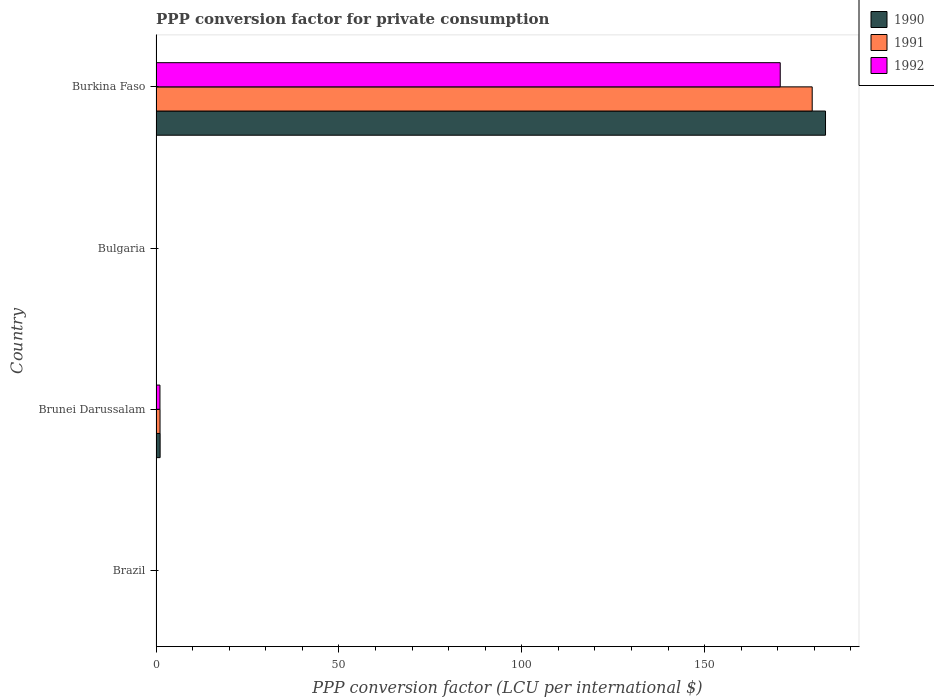How many different coloured bars are there?
Make the answer very short. 3. Are the number of bars on each tick of the Y-axis equal?
Provide a short and direct response. Yes. How many bars are there on the 4th tick from the top?
Give a very brief answer. 3. What is the label of the 3rd group of bars from the top?
Your answer should be compact. Brunei Darussalam. In how many cases, is the number of bars for a given country not equal to the number of legend labels?
Keep it short and to the point. 0. What is the PPP conversion factor for private consumption in 1990 in Brunei Darussalam?
Provide a succinct answer. 1.12. Across all countries, what is the maximum PPP conversion factor for private consumption in 1991?
Make the answer very short. 179.42. Across all countries, what is the minimum PPP conversion factor for private consumption in 1990?
Provide a succinct answer. 2.39117107766808e-5. In which country was the PPP conversion factor for private consumption in 1990 maximum?
Make the answer very short. Burkina Faso. What is the total PPP conversion factor for private consumption in 1991 in the graph?
Offer a very short reply. 180.51. What is the difference between the PPP conversion factor for private consumption in 1990 in Brazil and that in Bulgaria?
Give a very brief answer. -0. What is the difference between the PPP conversion factor for private consumption in 1990 in Brazil and the PPP conversion factor for private consumption in 1991 in Bulgaria?
Your answer should be very brief. -0. What is the average PPP conversion factor for private consumption in 1990 per country?
Ensure brevity in your answer.  46.04. What is the difference between the PPP conversion factor for private consumption in 1990 and PPP conversion factor for private consumption in 1991 in Brunei Darussalam?
Make the answer very short. 0.03. In how many countries, is the PPP conversion factor for private consumption in 1990 greater than 90 LCU?
Keep it short and to the point. 1. What is the ratio of the PPP conversion factor for private consumption in 1992 in Brazil to that in Brunei Darussalam?
Provide a short and direct response. 0. Is the PPP conversion factor for private consumption in 1992 in Brazil less than that in Brunei Darussalam?
Give a very brief answer. Yes. What is the difference between the highest and the second highest PPP conversion factor for private consumption in 1992?
Make the answer very short. 169.6. What is the difference between the highest and the lowest PPP conversion factor for private consumption in 1990?
Your answer should be compact. 183.06. Is the sum of the PPP conversion factor for private consumption in 1991 in Brunei Darussalam and Burkina Faso greater than the maximum PPP conversion factor for private consumption in 1990 across all countries?
Keep it short and to the point. No. What does the 3rd bar from the top in Brunei Darussalam represents?
Offer a terse response. 1990. Is it the case that in every country, the sum of the PPP conversion factor for private consumption in 1992 and PPP conversion factor for private consumption in 1990 is greater than the PPP conversion factor for private consumption in 1991?
Ensure brevity in your answer.  Yes. Are all the bars in the graph horizontal?
Your answer should be very brief. Yes. What is the difference between two consecutive major ticks on the X-axis?
Ensure brevity in your answer.  50. Does the graph contain any zero values?
Keep it short and to the point. No. Does the graph contain grids?
Your response must be concise. No. How are the legend labels stacked?
Your answer should be compact. Vertical. What is the title of the graph?
Your response must be concise. PPP conversion factor for private consumption. What is the label or title of the X-axis?
Provide a succinct answer. PPP conversion factor (LCU per international $). What is the PPP conversion factor (LCU per international $) of 1990 in Brazil?
Give a very brief answer. 2.39117107766808e-5. What is the PPP conversion factor (LCU per international $) in 1991 in Brazil?
Your answer should be very brief. 0. What is the PPP conversion factor (LCU per international $) in 1992 in Brazil?
Your answer should be very brief. 0. What is the PPP conversion factor (LCU per international $) in 1990 in Brunei Darussalam?
Give a very brief answer. 1.12. What is the PPP conversion factor (LCU per international $) of 1991 in Brunei Darussalam?
Offer a very short reply. 1.09. What is the PPP conversion factor (LCU per international $) in 1992 in Brunei Darussalam?
Give a very brief answer. 1.08. What is the PPP conversion factor (LCU per international $) of 1990 in Bulgaria?
Provide a short and direct response. 0. What is the PPP conversion factor (LCU per international $) in 1991 in Bulgaria?
Keep it short and to the point. 0. What is the PPP conversion factor (LCU per international $) of 1992 in Bulgaria?
Keep it short and to the point. 0. What is the PPP conversion factor (LCU per international $) in 1990 in Burkina Faso?
Give a very brief answer. 183.06. What is the PPP conversion factor (LCU per international $) in 1991 in Burkina Faso?
Give a very brief answer. 179.42. What is the PPP conversion factor (LCU per international $) in 1992 in Burkina Faso?
Your answer should be compact. 170.67. Across all countries, what is the maximum PPP conversion factor (LCU per international $) in 1990?
Ensure brevity in your answer.  183.06. Across all countries, what is the maximum PPP conversion factor (LCU per international $) of 1991?
Ensure brevity in your answer.  179.42. Across all countries, what is the maximum PPP conversion factor (LCU per international $) in 1992?
Offer a terse response. 170.67. Across all countries, what is the minimum PPP conversion factor (LCU per international $) in 1990?
Keep it short and to the point. 2.39117107766808e-5. Across all countries, what is the minimum PPP conversion factor (LCU per international $) in 1991?
Keep it short and to the point. 0. Across all countries, what is the minimum PPP conversion factor (LCU per international $) in 1992?
Your response must be concise. 0. What is the total PPP conversion factor (LCU per international $) in 1990 in the graph?
Give a very brief answer. 184.18. What is the total PPP conversion factor (LCU per international $) in 1991 in the graph?
Provide a succinct answer. 180.51. What is the total PPP conversion factor (LCU per international $) of 1992 in the graph?
Ensure brevity in your answer.  171.76. What is the difference between the PPP conversion factor (LCU per international $) in 1990 in Brazil and that in Brunei Darussalam?
Your answer should be compact. -1.12. What is the difference between the PPP conversion factor (LCU per international $) in 1991 in Brazil and that in Brunei Darussalam?
Keep it short and to the point. -1.09. What is the difference between the PPP conversion factor (LCU per international $) of 1992 in Brazil and that in Brunei Darussalam?
Your answer should be very brief. -1.07. What is the difference between the PPP conversion factor (LCU per international $) of 1990 in Brazil and that in Bulgaria?
Your answer should be compact. -0. What is the difference between the PPP conversion factor (LCU per international $) in 1991 in Brazil and that in Bulgaria?
Offer a terse response. -0. What is the difference between the PPP conversion factor (LCU per international $) in 1992 in Brazil and that in Bulgaria?
Keep it short and to the point. -0. What is the difference between the PPP conversion factor (LCU per international $) in 1990 in Brazil and that in Burkina Faso?
Your answer should be compact. -183.06. What is the difference between the PPP conversion factor (LCU per international $) of 1991 in Brazil and that in Burkina Faso?
Provide a succinct answer. -179.42. What is the difference between the PPP conversion factor (LCU per international $) of 1992 in Brazil and that in Burkina Faso?
Give a very brief answer. -170.67. What is the difference between the PPP conversion factor (LCU per international $) of 1990 in Brunei Darussalam and that in Bulgaria?
Offer a very short reply. 1.12. What is the difference between the PPP conversion factor (LCU per international $) in 1991 in Brunei Darussalam and that in Bulgaria?
Offer a very short reply. 1.09. What is the difference between the PPP conversion factor (LCU per international $) in 1992 in Brunei Darussalam and that in Bulgaria?
Make the answer very short. 1.07. What is the difference between the PPP conversion factor (LCU per international $) of 1990 in Brunei Darussalam and that in Burkina Faso?
Offer a very short reply. -181.93. What is the difference between the PPP conversion factor (LCU per international $) in 1991 in Brunei Darussalam and that in Burkina Faso?
Make the answer very short. -178.32. What is the difference between the PPP conversion factor (LCU per international $) in 1992 in Brunei Darussalam and that in Burkina Faso?
Provide a short and direct response. -169.6. What is the difference between the PPP conversion factor (LCU per international $) of 1990 in Bulgaria and that in Burkina Faso?
Make the answer very short. -183.06. What is the difference between the PPP conversion factor (LCU per international $) in 1991 in Bulgaria and that in Burkina Faso?
Keep it short and to the point. -179.41. What is the difference between the PPP conversion factor (LCU per international $) of 1992 in Bulgaria and that in Burkina Faso?
Ensure brevity in your answer.  -170.67. What is the difference between the PPP conversion factor (LCU per international $) of 1990 in Brazil and the PPP conversion factor (LCU per international $) of 1991 in Brunei Darussalam?
Your answer should be compact. -1.09. What is the difference between the PPP conversion factor (LCU per international $) of 1990 in Brazil and the PPP conversion factor (LCU per international $) of 1992 in Brunei Darussalam?
Offer a terse response. -1.08. What is the difference between the PPP conversion factor (LCU per international $) of 1991 in Brazil and the PPP conversion factor (LCU per international $) of 1992 in Brunei Darussalam?
Your answer should be very brief. -1.08. What is the difference between the PPP conversion factor (LCU per international $) of 1990 in Brazil and the PPP conversion factor (LCU per international $) of 1991 in Bulgaria?
Offer a terse response. -0. What is the difference between the PPP conversion factor (LCU per international $) in 1990 in Brazil and the PPP conversion factor (LCU per international $) in 1992 in Bulgaria?
Your response must be concise. -0. What is the difference between the PPP conversion factor (LCU per international $) in 1991 in Brazil and the PPP conversion factor (LCU per international $) in 1992 in Bulgaria?
Make the answer very short. -0. What is the difference between the PPP conversion factor (LCU per international $) of 1990 in Brazil and the PPP conversion factor (LCU per international $) of 1991 in Burkina Faso?
Make the answer very short. -179.42. What is the difference between the PPP conversion factor (LCU per international $) of 1990 in Brazil and the PPP conversion factor (LCU per international $) of 1992 in Burkina Faso?
Your response must be concise. -170.67. What is the difference between the PPP conversion factor (LCU per international $) in 1991 in Brazil and the PPP conversion factor (LCU per international $) in 1992 in Burkina Faso?
Give a very brief answer. -170.67. What is the difference between the PPP conversion factor (LCU per international $) in 1990 in Brunei Darussalam and the PPP conversion factor (LCU per international $) in 1991 in Bulgaria?
Make the answer very short. 1.12. What is the difference between the PPP conversion factor (LCU per international $) of 1990 in Brunei Darussalam and the PPP conversion factor (LCU per international $) of 1992 in Bulgaria?
Keep it short and to the point. 1.12. What is the difference between the PPP conversion factor (LCU per international $) of 1991 in Brunei Darussalam and the PPP conversion factor (LCU per international $) of 1992 in Bulgaria?
Ensure brevity in your answer.  1.09. What is the difference between the PPP conversion factor (LCU per international $) of 1990 in Brunei Darussalam and the PPP conversion factor (LCU per international $) of 1991 in Burkina Faso?
Keep it short and to the point. -178.29. What is the difference between the PPP conversion factor (LCU per international $) of 1990 in Brunei Darussalam and the PPP conversion factor (LCU per international $) of 1992 in Burkina Faso?
Ensure brevity in your answer.  -169.55. What is the difference between the PPP conversion factor (LCU per international $) of 1991 in Brunei Darussalam and the PPP conversion factor (LCU per international $) of 1992 in Burkina Faso?
Your answer should be very brief. -169.58. What is the difference between the PPP conversion factor (LCU per international $) of 1990 in Bulgaria and the PPP conversion factor (LCU per international $) of 1991 in Burkina Faso?
Your answer should be compact. -179.42. What is the difference between the PPP conversion factor (LCU per international $) in 1990 in Bulgaria and the PPP conversion factor (LCU per international $) in 1992 in Burkina Faso?
Your response must be concise. -170.67. What is the difference between the PPP conversion factor (LCU per international $) in 1991 in Bulgaria and the PPP conversion factor (LCU per international $) in 1992 in Burkina Faso?
Keep it short and to the point. -170.67. What is the average PPP conversion factor (LCU per international $) in 1990 per country?
Provide a succinct answer. 46.05. What is the average PPP conversion factor (LCU per international $) of 1991 per country?
Your answer should be compact. 45.13. What is the average PPP conversion factor (LCU per international $) in 1992 per country?
Your answer should be very brief. 42.94. What is the difference between the PPP conversion factor (LCU per international $) in 1990 and PPP conversion factor (LCU per international $) in 1991 in Brazil?
Your answer should be very brief. -0. What is the difference between the PPP conversion factor (LCU per international $) in 1990 and PPP conversion factor (LCU per international $) in 1992 in Brazil?
Make the answer very short. -0. What is the difference between the PPP conversion factor (LCU per international $) in 1991 and PPP conversion factor (LCU per international $) in 1992 in Brazil?
Ensure brevity in your answer.  -0. What is the difference between the PPP conversion factor (LCU per international $) of 1990 and PPP conversion factor (LCU per international $) of 1991 in Brunei Darussalam?
Keep it short and to the point. 0.03. What is the difference between the PPP conversion factor (LCU per international $) of 1990 and PPP conversion factor (LCU per international $) of 1992 in Brunei Darussalam?
Provide a succinct answer. 0.05. What is the difference between the PPP conversion factor (LCU per international $) of 1991 and PPP conversion factor (LCU per international $) of 1992 in Brunei Darussalam?
Your answer should be compact. 0.02. What is the difference between the PPP conversion factor (LCU per international $) of 1990 and PPP conversion factor (LCU per international $) of 1991 in Bulgaria?
Make the answer very short. -0. What is the difference between the PPP conversion factor (LCU per international $) of 1990 and PPP conversion factor (LCU per international $) of 1992 in Bulgaria?
Ensure brevity in your answer.  -0. What is the difference between the PPP conversion factor (LCU per international $) of 1991 and PPP conversion factor (LCU per international $) of 1992 in Bulgaria?
Your answer should be compact. -0. What is the difference between the PPP conversion factor (LCU per international $) in 1990 and PPP conversion factor (LCU per international $) in 1991 in Burkina Faso?
Offer a terse response. 3.64. What is the difference between the PPP conversion factor (LCU per international $) of 1990 and PPP conversion factor (LCU per international $) of 1992 in Burkina Faso?
Offer a terse response. 12.38. What is the difference between the PPP conversion factor (LCU per international $) in 1991 and PPP conversion factor (LCU per international $) in 1992 in Burkina Faso?
Keep it short and to the point. 8.74. What is the ratio of the PPP conversion factor (LCU per international $) of 1991 in Brazil to that in Brunei Darussalam?
Offer a terse response. 0. What is the ratio of the PPP conversion factor (LCU per international $) in 1992 in Brazil to that in Brunei Darussalam?
Your response must be concise. 0. What is the ratio of the PPP conversion factor (LCU per international $) in 1990 in Brazil to that in Bulgaria?
Your answer should be very brief. 0.04. What is the ratio of the PPP conversion factor (LCU per international $) in 1991 in Brazil to that in Bulgaria?
Your response must be concise. 0.05. What is the ratio of the PPP conversion factor (LCU per international $) of 1992 in Brazil to that in Bulgaria?
Your answer should be compact. 0.25. What is the ratio of the PPP conversion factor (LCU per international $) of 1991 in Brazil to that in Burkina Faso?
Keep it short and to the point. 0. What is the ratio of the PPP conversion factor (LCU per international $) in 1990 in Brunei Darussalam to that in Bulgaria?
Ensure brevity in your answer.  1773.71. What is the ratio of the PPP conversion factor (LCU per international $) of 1991 in Brunei Darussalam to that in Bulgaria?
Your answer should be very brief. 411.02. What is the ratio of the PPP conversion factor (LCU per international $) in 1992 in Brunei Darussalam to that in Bulgaria?
Your answer should be compact. 217.61. What is the ratio of the PPP conversion factor (LCU per international $) in 1990 in Brunei Darussalam to that in Burkina Faso?
Your response must be concise. 0.01. What is the ratio of the PPP conversion factor (LCU per international $) of 1991 in Brunei Darussalam to that in Burkina Faso?
Provide a short and direct response. 0.01. What is the ratio of the PPP conversion factor (LCU per international $) of 1992 in Brunei Darussalam to that in Burkina Faso?
Offer a very short reply. 0.01. What is the ratio of the PPP conversion factor (LCU per international $) in 1990 in Bulgaria to that in Burkina Faso?
Your answer should be very brief. 0. What is the ratio of the PPP conversion factor (LCU per international $) in 1992 in Bulgaria to that in Burkina Faso?
Ensure brevity in your answer.  0. What is the difference between the highest and the second highest PPP conversion factor (LCU per international $) of 1990?
Your answer should be compact. 181.93. What is the difference between the highest and the second highest PPP conversion factor (LCU per international $) in 1991?
Your response must be concise. 178.32. What is the difference between the highest and the second highest PPP conversion factor (LCU per international $) in 1992?
Provide a short and direct response. 169.6. What is the difference between the highest and the lowest PPP conversion factor (LCU per international $) of 1990?
Offer a terse response. 183.06. What is the difference between the highest and the lowest PPP conversion factor (LCU per international $) in 1991?
Your answer should be very brief. 179.42. What is the difference between the highest and the lowest PPP conversion factor (LCU per international $) of 1992?
Your response must be concise. 170.67. 